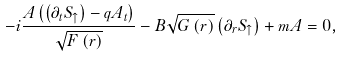Convert formula to latex. <formula><loc_0><loc_0><loc_500><loc_500>- i \frac { A \left ( \left ( \partial _ { t } S _ { \uparrow } \right ) - q A _ { t } \right ) } { \sqrt { F \left ( r \right ) } } - B \sqrt { G \left ( r \right ) } \left ( \partial _ { r } S _ { \uparrow } \right ) + m A = 0 ,</formula> 